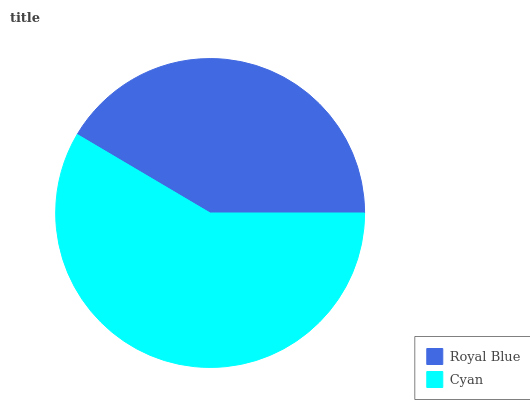Is Royal Blue the minimum?
Answer yes or no. Yes. Is Cyan the maximum?
Answer yes or no. Yes. Is Cyan the minimum?
Answer yes or no. No. Is Cyan greater than Royal Blue?
Answer yes or no. Yes. Is Royal Blue less than Cyan?
Answer yes or no. Yes. Is Royal Blue greater than Cyan?
Answer yes or no. No. Is Cyan less than Royal Blue?
Answer yes or no. No. Is Cyan the high median?
Answer yes or no. Yes. Is Royal Blue the low median?
Answer yes or no. Yes. Is Royal Blue the high median?
Answer yes or no. No. Is Cyan the low median?
Answer yes or no. No. 